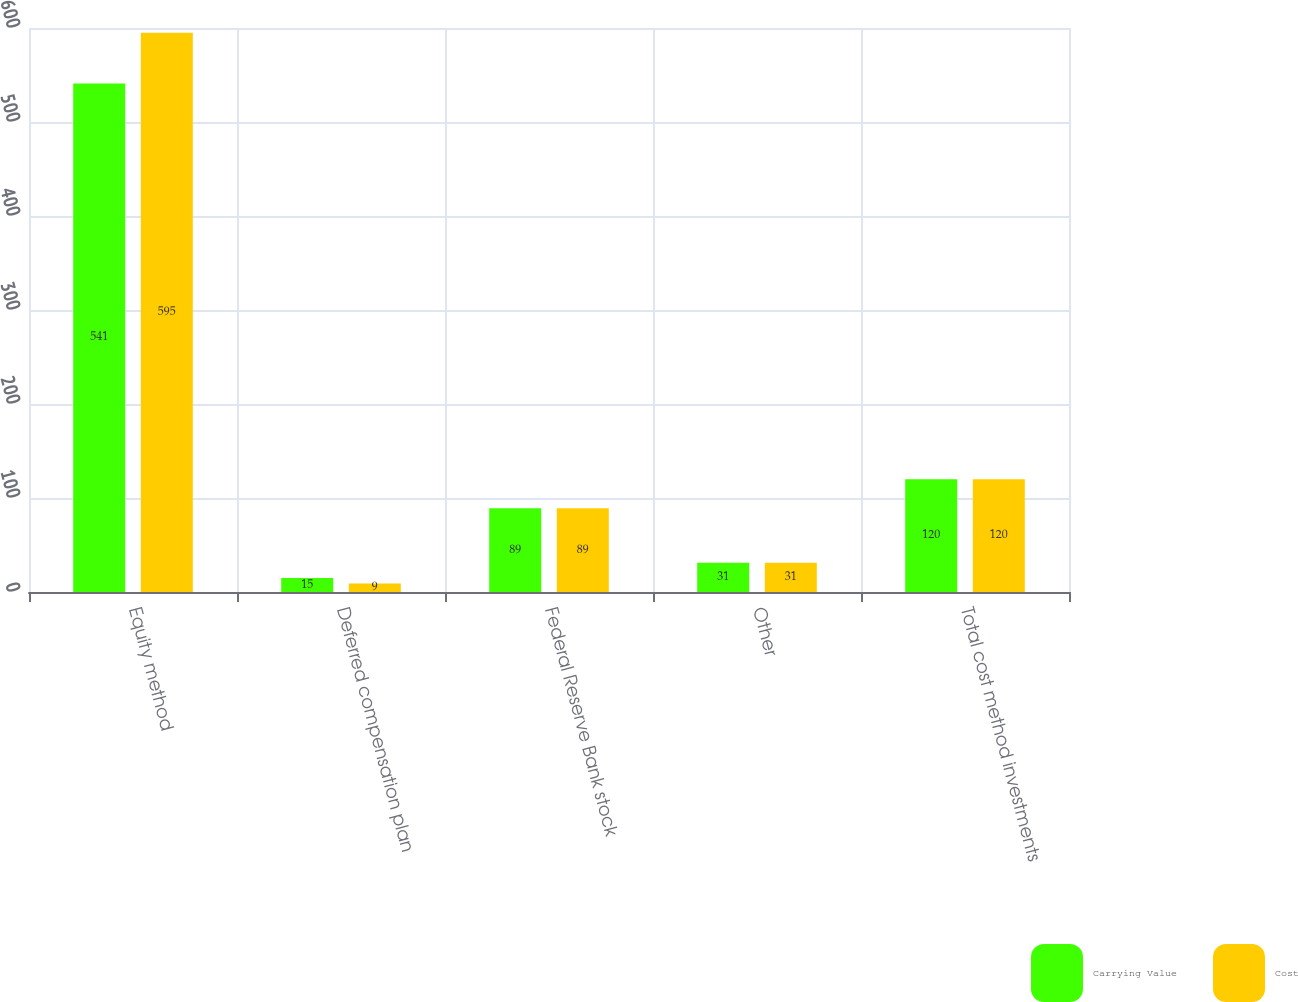Convert chart. <chart><loc_0><loc_0><loc_500><loc_500><stacked_bar_chart><ecel><fcel>Equity method<fcel>Deferred compensation plan<fcel>Federal Reserve Bank stock<fcel>Other<fcel>Total cost method investments<nl><fcel>Carrying Value<fcel>541<fcel>15<fcel>89<fcel>31<fcel>120<nl><fcel>Cost<fcel>595<fcel>9<fcel>89<fcel>31<fcel>120<nl></chart> 